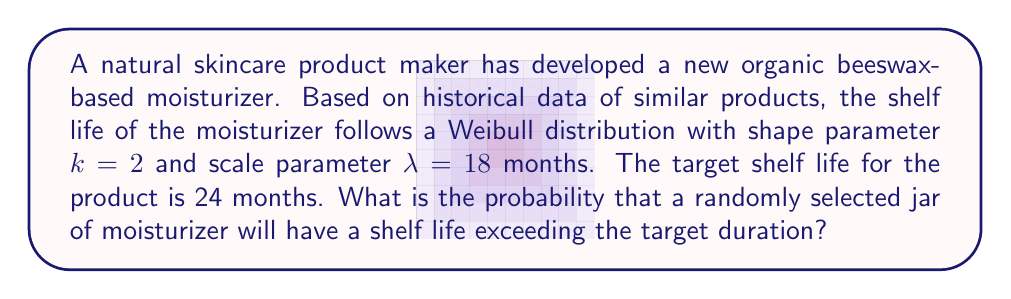Help me with this question. To solve this problem, we'll use the survival function of the Weibull distribution, which gives the probability that a random variable X is greater than a specified value x.

Step 1: Recall the survival function for the Weibull distribution:
$$S(x) = P(X > x) = e^{-(\frac{x}{\lambda})^k}$$

Step 2: Substitute the given values:
$k = 2$ (shape parameter)
$\lambda = 18$ (scale parameter)
$x = 24$ (target shelf life)

Step 3: Apply the survival function:
$$P(X > 24) = e^{-(\frac{24}{18})^2}$$

Step 4: Simplify the expression inside the parentheses:
$$P(X > 24) = e^{-(\frac{4}{3})^2}$$

Step 5: Calculate the value:
$$P(X > 24) = e^{-(\frac{16}{9})} \approx 0.1653$$

Therefore, the probability that a randomly selected jar of moisturizer will have a shelf life exceeding 24 months is approximately 0.1653 or 16.53%.
Answer: $0.1653$ or $16.53\%$ 